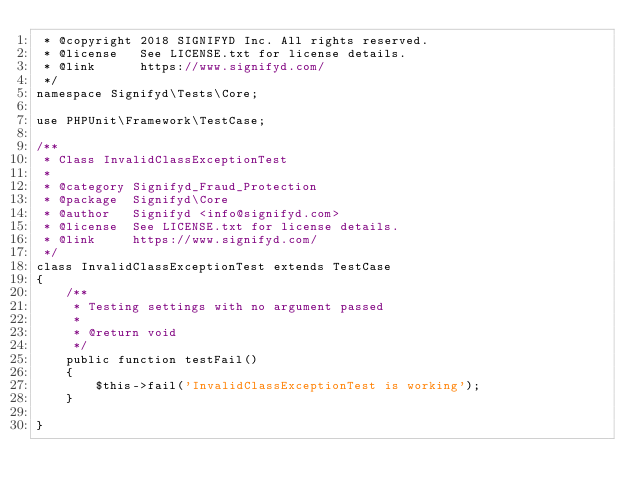<code> <loc_0><loc_0><loc_500><loc_500><_PHP_> * @copyright 2018 SIGNIFYD Inc. All rights reserved.
 * @license   See LICENSE.txt for license details.
 * @link      https://www.signifyd.com/
 */
namespace Signifyd\Tests\Core;

use PHPUnit\Framework\TestCase;

/**
 * Class InvalidClassExceptionTest
 *
 * @category Signifyd_Fraud_Protection
 * @package  Signifyd\Core
 * @author   Signifyd <info@signifyd.com>
 * @license  See LICENSE.txt for license details.
 * @link     https://www.signifyd.com/
 */
class InvalidClassExceptionTest extends TestCase
{
    /**
     * Testing settings with no argument passed
     *
     * @return void
     */
    public function testFail()
    {
        $this->fail('InvalidClassExceptionTest is working');
    }

}</code> 